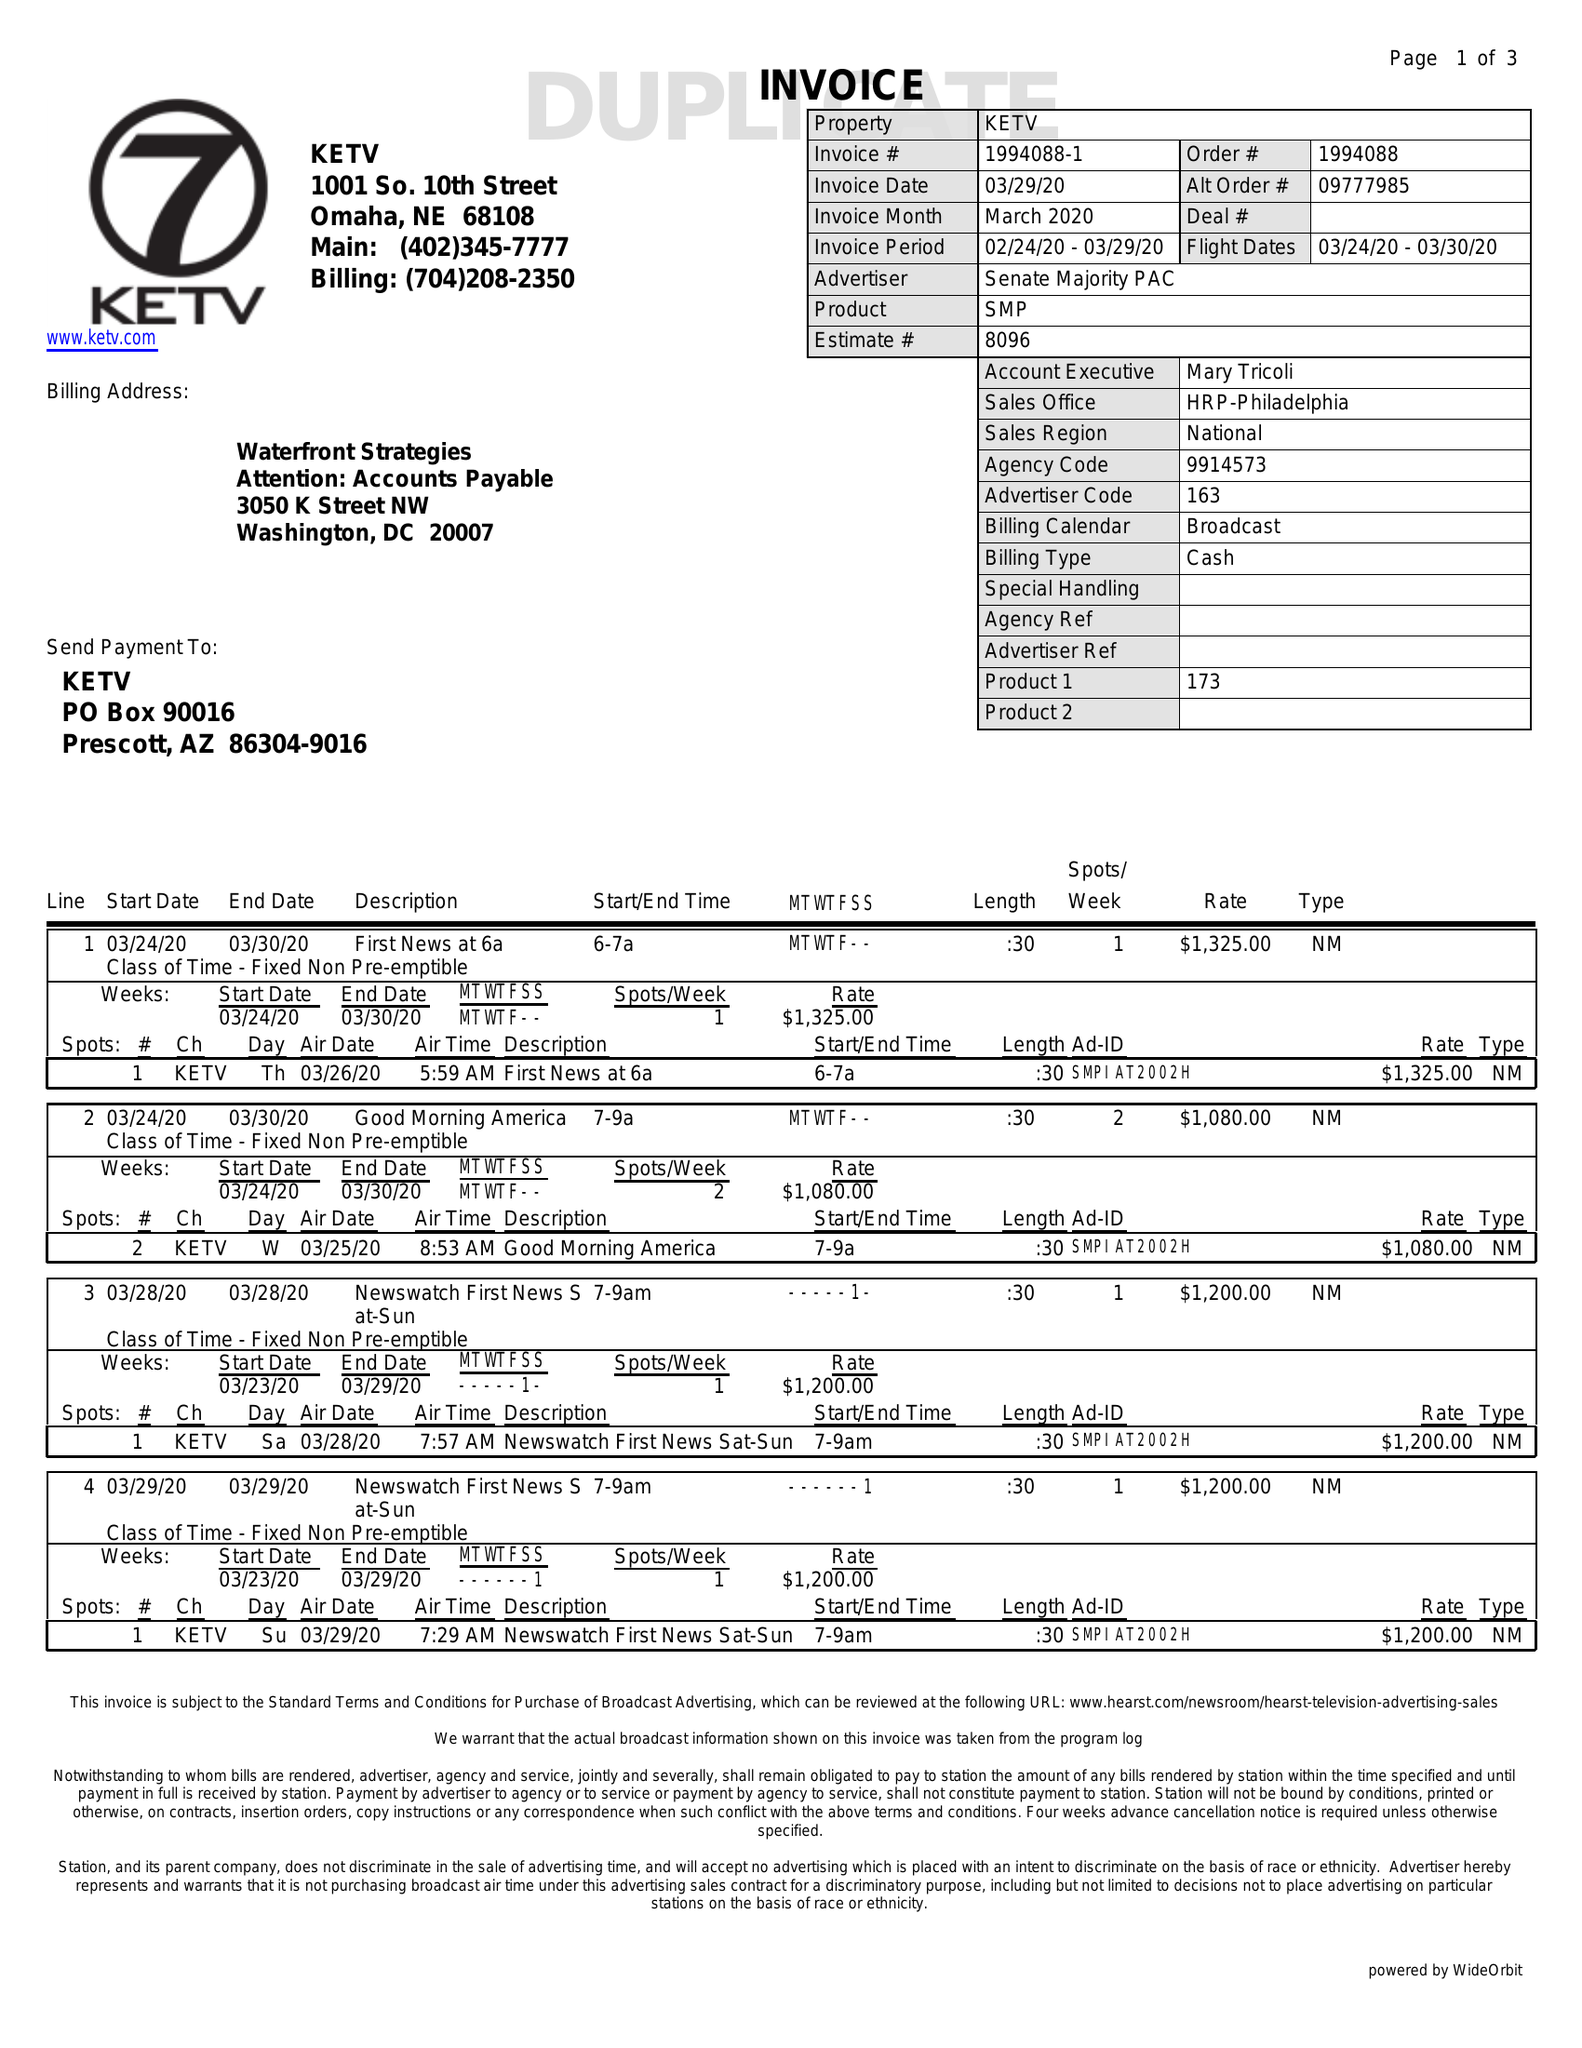What is the value for the contract_num?
Answer the question using a single word or phrase. 1994088 